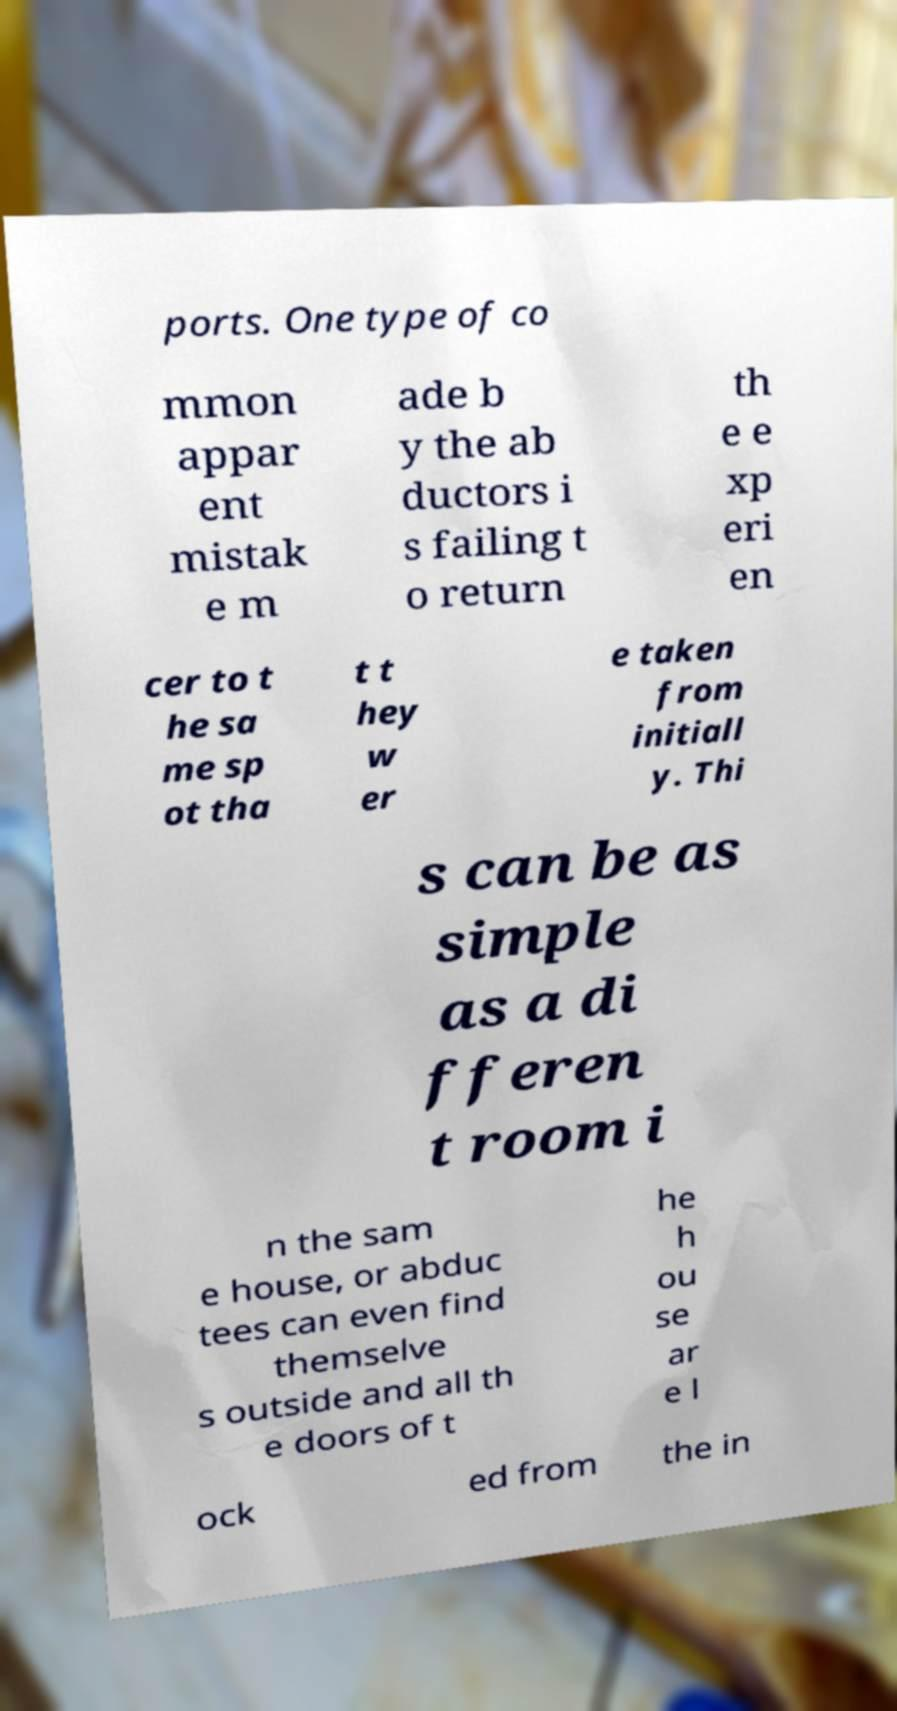I need the written content from this picture converted into text. Can you do that? ports. One type of co mmon appar ent mistak e m ade b y the ab ductors i s failing t o return th e e xp eri en cer to t he sa me sp ot tha t t hey w er e taken from initiall y. Thi s can be as simple as a di fferen t room i n the sam e house, or abduc tees can even find themselve s outside and all th e doors of t he h ou se ar e l ock ed from the in 